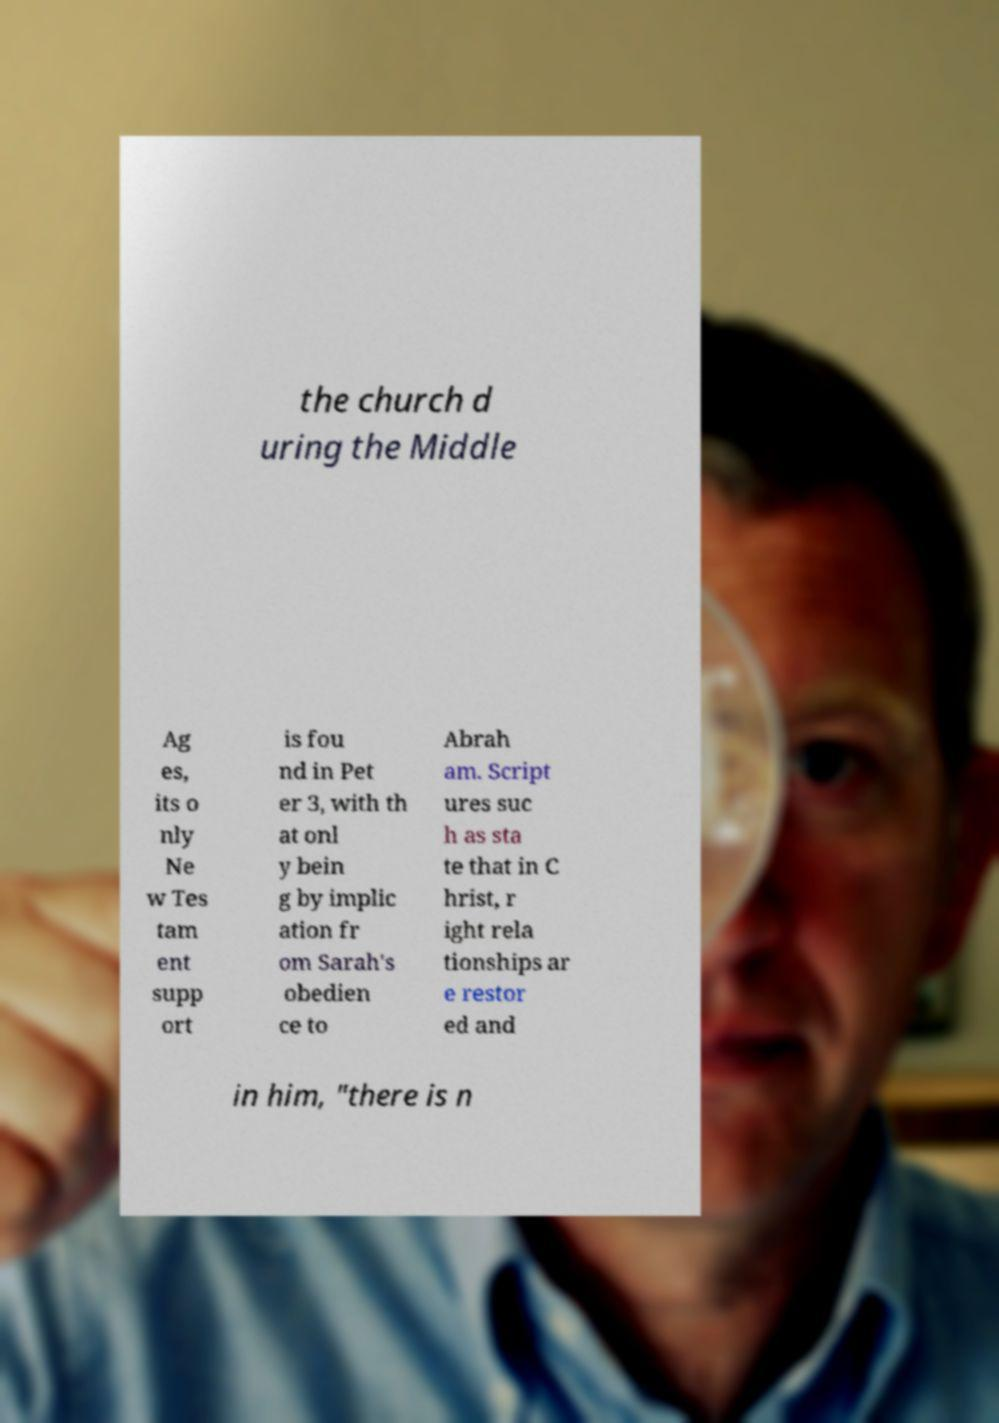Could you assist in decoding the text presented in this image and type it out clearly? the church d uring the Middle Ag es, its o nly Ne w Tes tam ent supp ort is fou nd in Pet er 3, with th at onl y bein g by implic ation fr om Sarah's obedien ce to Abrah am. Script ures suc h as sta te that in C hrist, r ight rela tionships ar e restor ed and in him, "there is n 